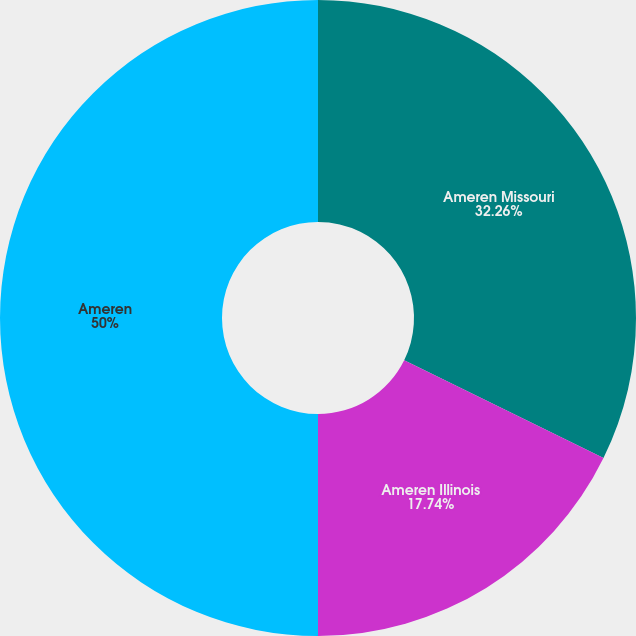Convert chart. <chart><loc_0><loc_0><loc_500><loc_500><pie_chart><fcel>Ameren Missouri<fcel>Ameren Illinois<fcel>Ameren<nl><fcel>32.26%<fcel>17.74%<fcel>50.0%<nl></chart> 